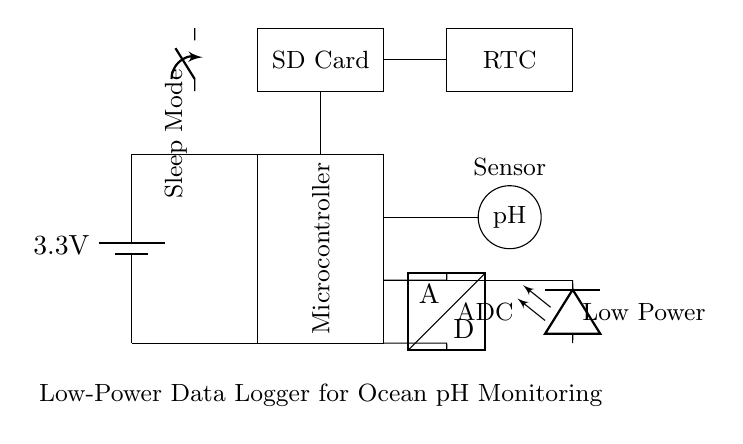What is the power supply voltage for this circuit? The power supply voltage is indicated next to the battery symbol, which shows a voltage of 3.3 volts.
Answer: 3.3 volts What component is used for data storage? The data storage component is represented as a rectangle labeled "SD Card," which is where data can be saved in this circuit.
Answer: SD Card How does the circuit indicate low power status? The circuit indicates low power status through an LED component labeled "Low Power," which lights up when the circuit is operating in low power mode.
Answer: Low Power LED Which component is responsible for converting the pH sensor's signal? The component responsible for converting the signal from the pH sensor to a digital format is labeled as "ADC," which stands for Analog to Digital Converter.
Answer: ADC What role does the RTC play in this circuit? The RTC, or Real-Time Clock, is used in the circuit to keep track of time for timestamping the pH data collected by the logger, ensuring that readings are appropriately logged.
Answer: Real-Time Clock What action does the Sleep Mode switch perform when activated? The Sleep Mode switch, when activated, puts the circuit into a low power state, reducing power consumption until it is reactivated for data logging or processing tasks.
Answer: Sleep Mode Why is a low-power design essential for this data logger? A low-power design is essential for this data logger because it allows the device to operate for extended periods without frequent battery replacement, which is vital for long-term monitoring of ocean pH levels in remote locations.
Answer: Low-power design 